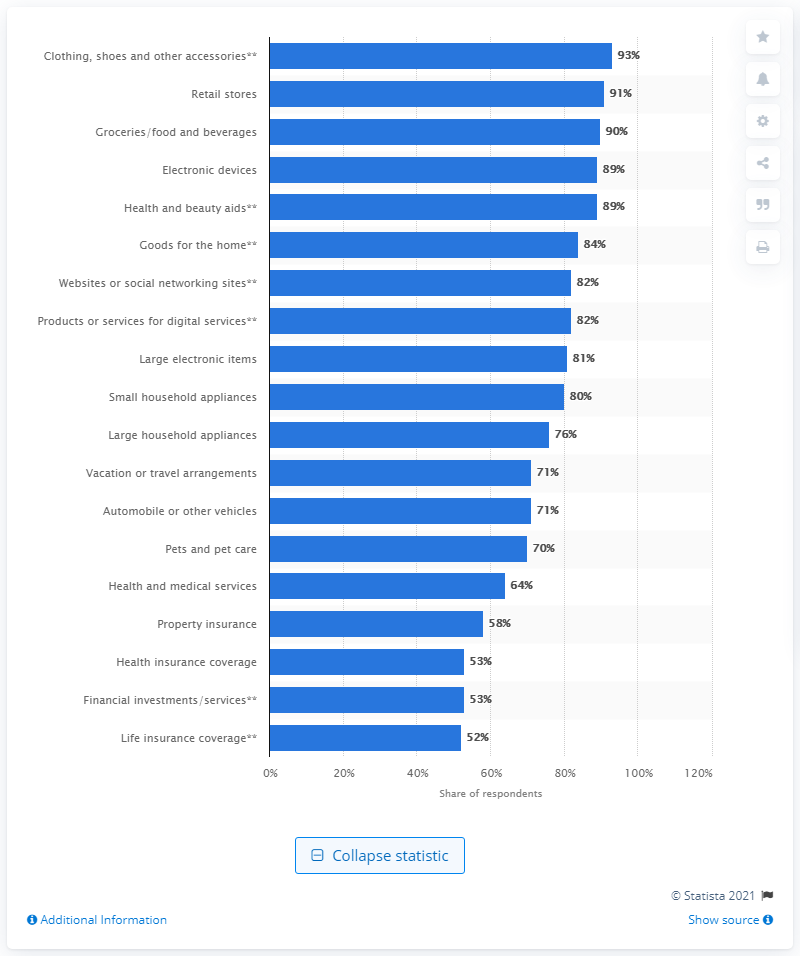Point out several critical features in this image. According to the survey, 93% of millennial mothers are willing to share information about retail stores with others. 